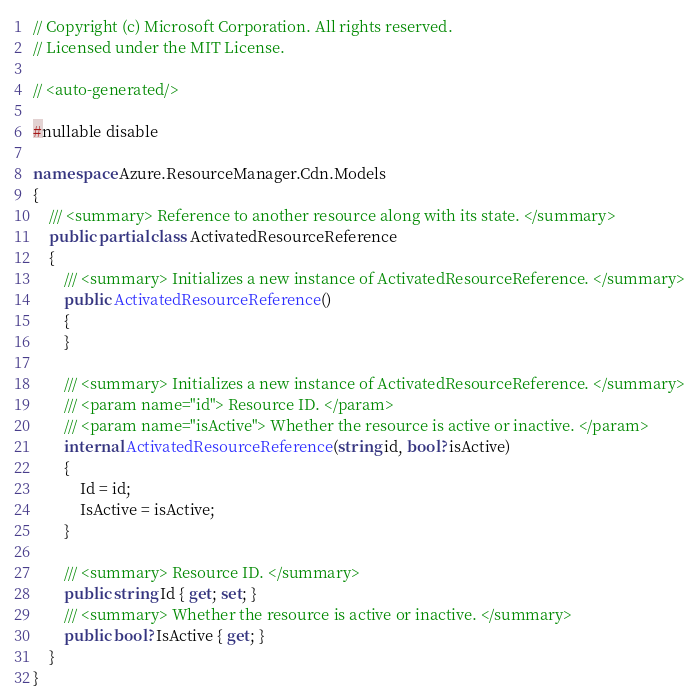Convert code to text. <code><loc_0><loc_0><loc_500><loc_500><_C#_>// Copyright (c) Microsoft Corporation. All rights reserved.
// Licensed under the MIT License.

// <auto-generated/>

#nullable disable

namespace Azure.ResourceManager.Cdn.Models
{
    /// <summary> Reference to another resource along with its state. </summary>
    public partial class ActivatedResourceReference
    {
        /// <summary> Initializes a new instance of ActivatedResourceReference. </summary>
        public ActivatedResourceReference()
        {
        }

        /// <summary> Initializes a new instance of ActivatedResourceReference. </summary>
        /// <param name="id"> Resource ID. </param>
        /// <param name="isActive"> Whether the resource is active or inactive. </param>
        internal ActivatedResourceReference(string id, bool? isActive)
        {
            Id = id;
            IsActive = isActive;
        }

        /// <summary> Resource ID. </summary>
        public string Id { get; set; }
        /// <summary> Whether the resource is active or inactive. </summary>
        public bool? IsActive { get; }
    }
}
</code> 